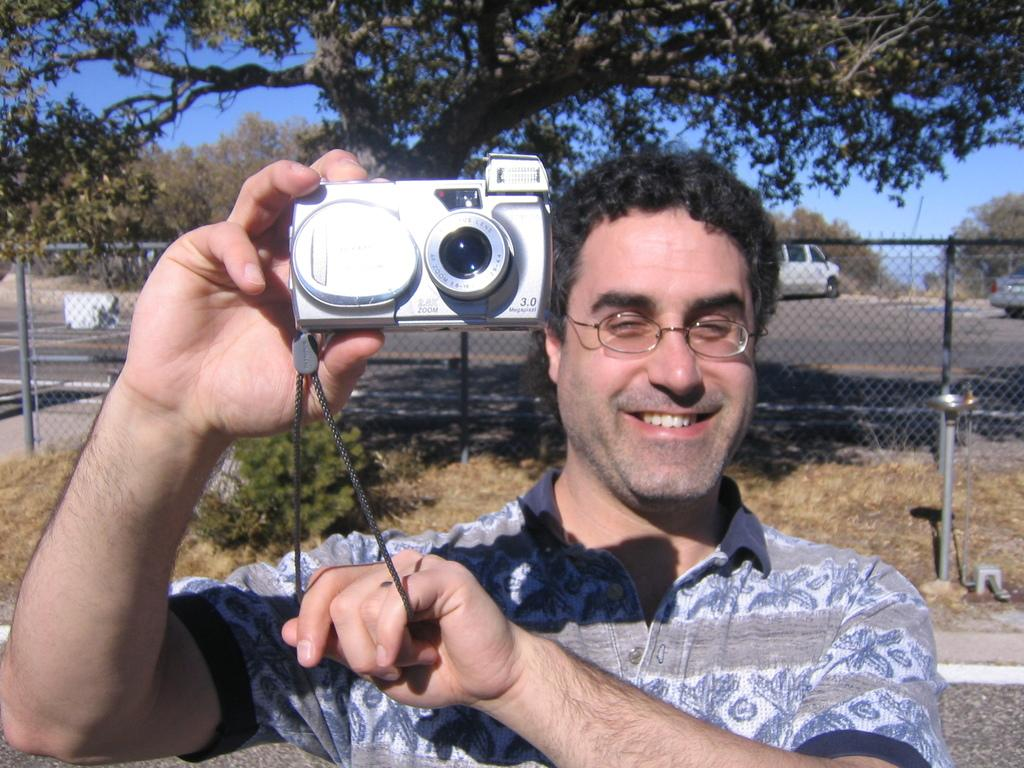What is the man in the image doing? The man in the image is holding a camera. What is the man's facial expression in the image? The man is smiling in the image. What can be seen in the background of the image? There is fencing and trees visible in the image. Are there any vehicles present in the image? Yes, there are cars present in the image. What type of argument is the man having with the army in the image? There is no army or argument present in the image; it only features a man holding a camera and smiling. Can you tell me what the man is writing with using a quill in the image? There is no quill or writing activity present in the image; the man is holding a camera. 